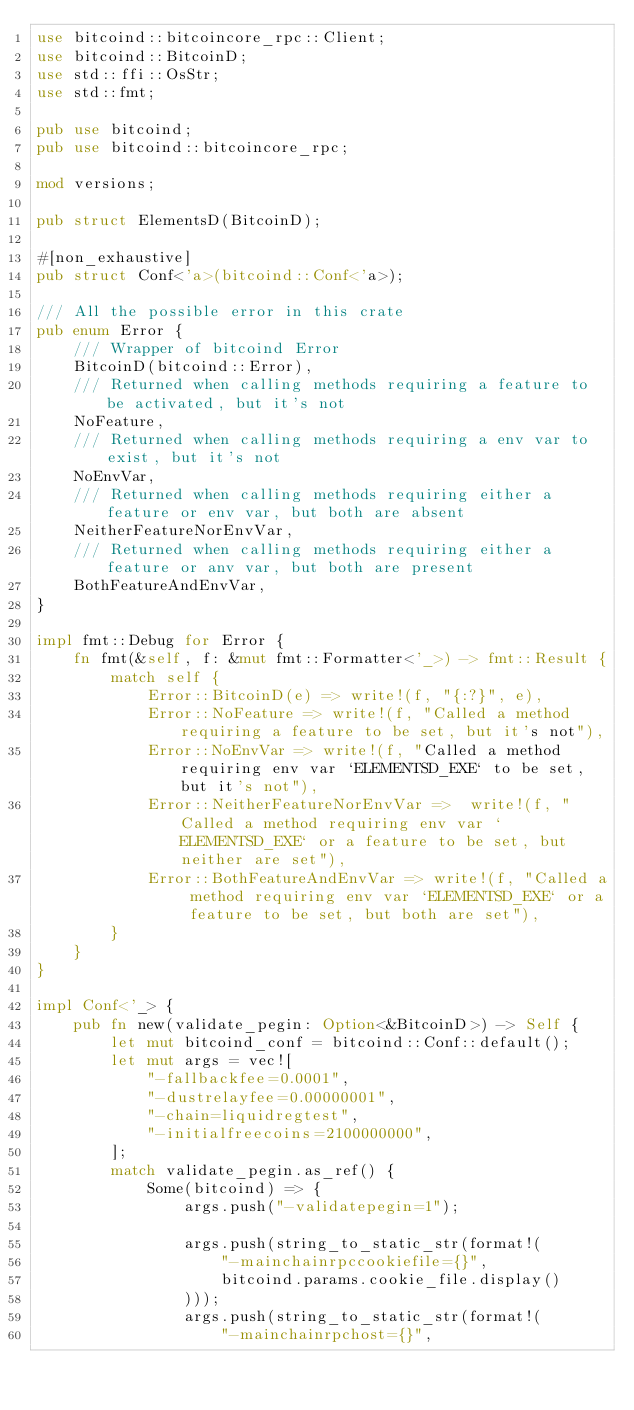<code> <loc_0><loc_0><loc_500><loc_500><_Rust_>use bitcoind::bitcoincore_rpc::Client;
use bitcoind::BitcoinD;
use std::ffi::OsStr;
use std::fmt;

pub use bitcoind;
pub use bitcoind::bitcoincore_rpc;

mod versions;

pub struct ElementsD(BitcoinD);

#[non_exhaustive]
pub struct Conf<'a>(bitcoind::Conf<'a>);

/// All the possible error in this crate
pub enum Error {
    /// Wrapper of bitcoind Error
    BitcoinD(bitcoind::Error),
    /// Returned when calling methods requiring a feature to be activated, but it's not
    NoFeature,
    /// Returned when calling methods requiring a env var to exist, but it's not
    NoEnvVar,
    /// Returned when calling methods requiring either a feature or env var, but both are absent
    NeitherFeatureNorEnvVar,
    /// Returned when calling methods requiring either a feature or anv var, but both are present
    BothFeatureAndEnvVar,
}

impl fmt::Debug for Error {
    fn fmt(&self, f: &mut fmt::Formatter<'_>) -> fmt::Result {
        match self {
            Error::BitcoinD(e) => write!(f, "{:?}", e),
            Error::NoFeature => write!(f, "Called a method requiring a feature to be set, but it's not"),
            Error::NoEnvVar => write!(f, "Called a method requiring env var `ELEMENTSD_EXE` to be set, but it's not"),
            Error::NeitherFeatureNorEnvVar =>  write!(f, "Called a method requiring env var `ELEMENTSD_EXE` or a feature to be set, but neither are set"),
            Error::BothFeatureAndEnvVar => write!(f, "Called a method requiring env var `ELEMENTSD_EXE` or a feature to be set, but both are set"),
        }
    }
}

impl Conf<'_> {
    pub fn new(validate_pegin: Option<&BitcoinD>) -> Self {
        let mut bitcoind_conf = bitcoind::Conf::default();
        let mut args = vec![
            "-fallbackfee=0.0001",
            "-dustrelayfee=0.00000001",
            "-chain=liquidregtest",
            "-initialfreecoins=2100000000",
        ];
        match validate_pegin.as_ref() {
            Some(bitcoind) => {
                args.push("-validatepegin=1");

                args.push(string_to_static_str(format!(
                    "-mainchainrpccookiefile={}",
                    bitcoind.params.cookie_file.display()
                )));
                args.push(string_to_static_str(format!(
                    "-mainchainrpchost={}",</code> 